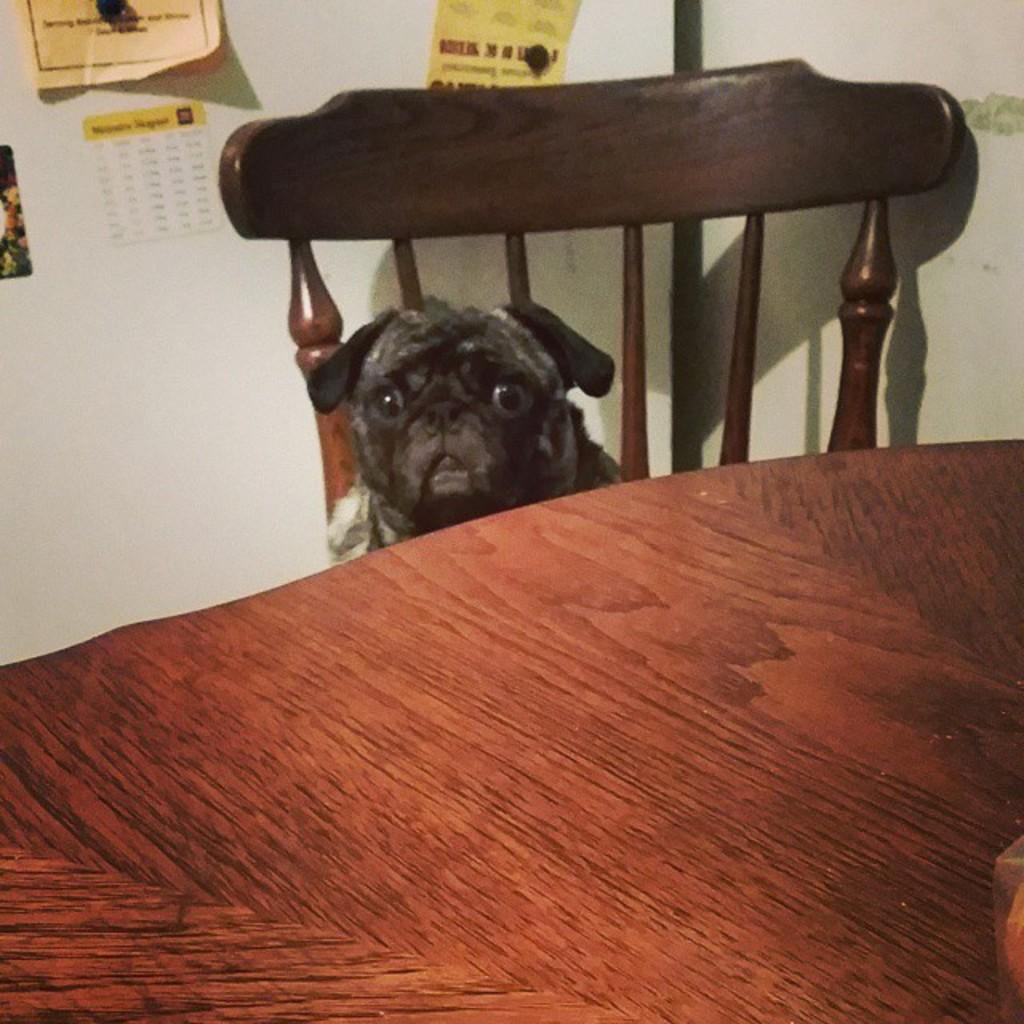What type of furniture is present in the image? There is a table and a chair in the image. What living creature can be seen in the image? There is a dog in the image. What type of structure is visible in the image? There is a wall in the image. What decorative items are on the wall? There are posters on the wall. What is the effect of the thunder on the dog in the image? There is no thunder present in the image, so there is no effect on the dog. How much of the wall is covered by the posters in the image? The amount of the wall covered by the posters cannot be determined from the image alone, as we cannot see the entire wall. 